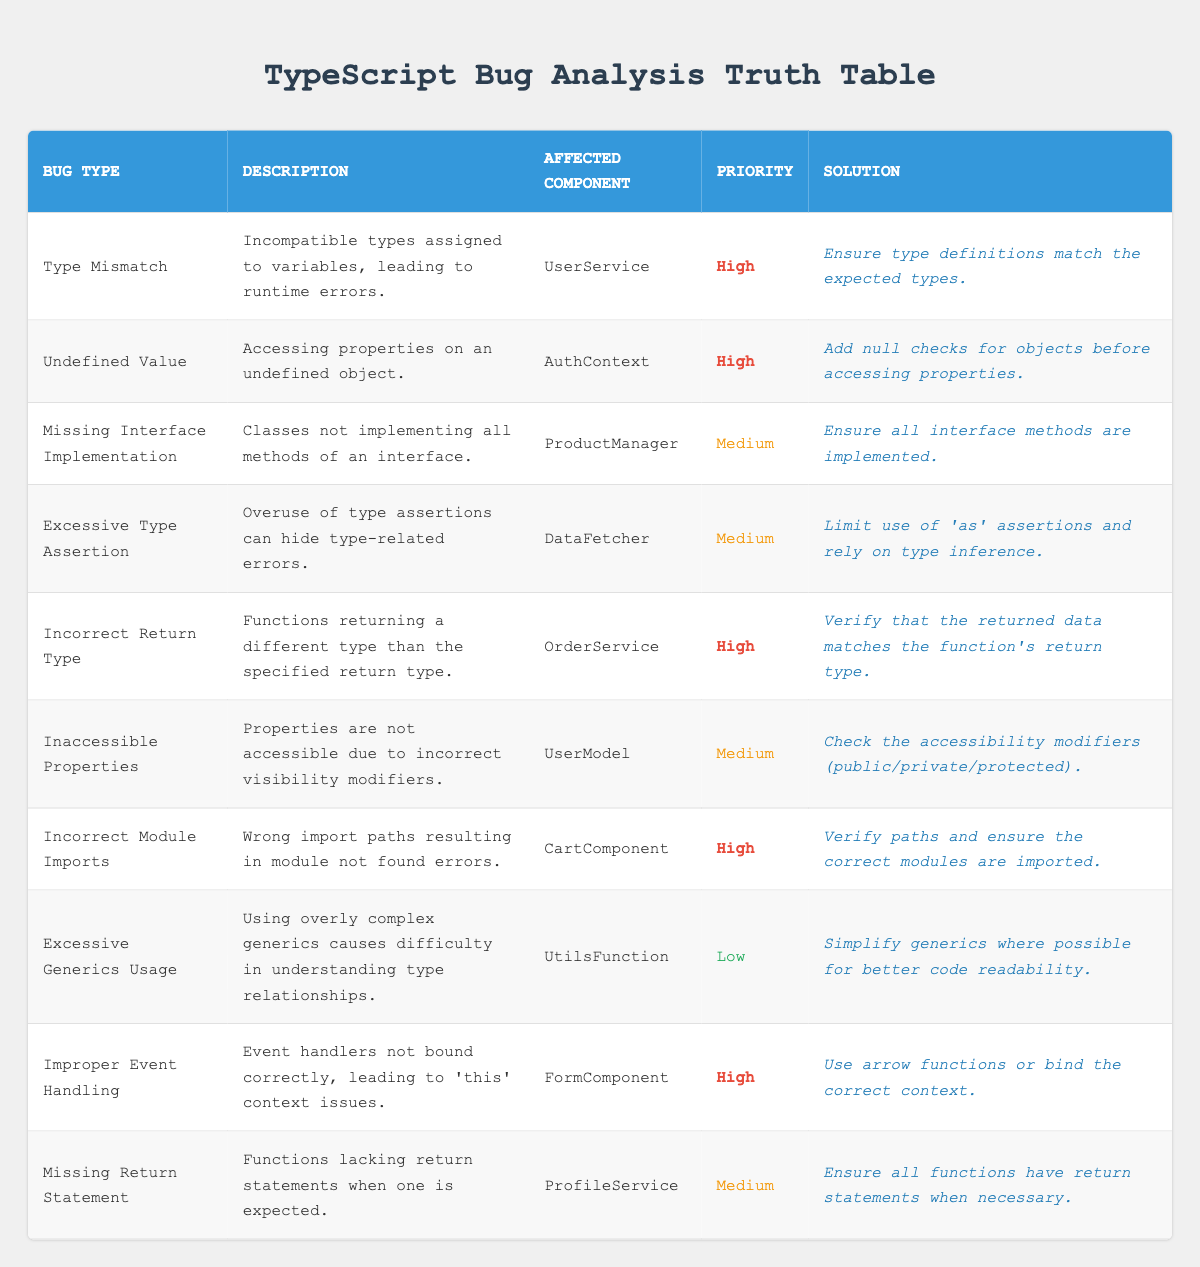What is the priority of the bug type 'Undefined Value'? In the table, look for the row where the bug type is 'Undefined Value'. The priority for this bug is listed under the Priority column, which shows 'High'.
Answer: High How many bug types have a priority level of 'High'? To find this, count the number of rows in the table that have 'High' listed under the Priority column. There are four entries: 'Type Mismatch', 'Undefined Value', 'Incorrect Return Type', and 'Incorrect Module Imports'.
Answer: 4 Is there any bug type with a 'Low' priority and what is its description? Check the table for any entries with 'Low' in the Priority column and see the corresponding description. The entry is 'Excessive Generics Usage', which has the description of "Using overly complex generics causes difficulty in understanding type relationships."
Answer: Yes, Excessive Generics Usage: Using overly complex generics causes difficulty in understanding type relationships Which component is most frequently affected by bugs with 'Medium' priority? Examine all the rows with 'Medium' priority and note the different affected components. The components are 'ProductManager', 'DataFetcher', 'UserModel', and 'ProfileService', each appearing once. Since there is no component that appears more than once among medium priorities, no single component is the most frequently affected.
Answer: None, all affected components appear equally What is the solution recommended for the bug type 'Incorrect Return Type'? Find the row for 'Incorrect Return Type' in the table. The corresponding solution is listed in the last column, which states "Verify that the returned data matches the function's return type."
Answer: Verify that the returned data matches the function's return type How many different affected components are listed in the table? Review the affected components in each row and note any duplicates. The unique affected components are 'UserService', 'AuthContext', 'ProductManager', 'DataFetcher', 'OrderService', 'UserModel', 'CartComponent', 'UtilsFunction', and 'FormComponent', which totals nine distinct components.
Answer: 9 Which bug type has the solution 'Add null checks for objects before accessing properties'? Search for the solution in the table and find which bug type corresponds to it. The solution belongs to the 'Undefined Value' bug type.
Answer: Undefined Value What is the description of the bug type with the lowest priority? Identify the row with 'Low' priority and read the description from that row. The bug type is 'Excessive Generics Usage', and its description is "Using overly complex generics causes difficulty in understanding type relationships."
Answer: Using overly complex generics causes difficulty in understanding type relationships 